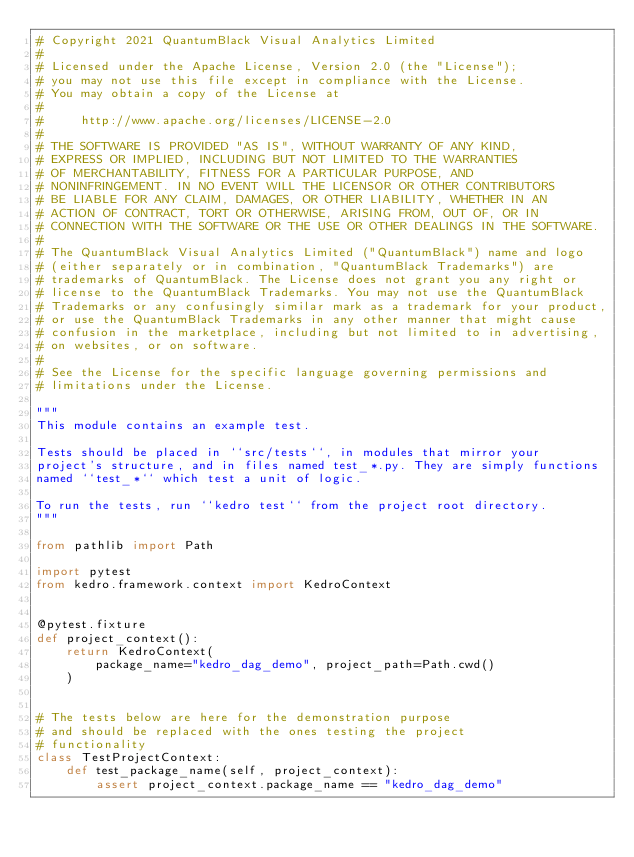<code> <loc_0><loc_0><loc_500><loc_500><_Python_># Copyright 2021 QuantumBlack Visual Analytics Limited
#
# Licensed under the Apache License, Version 2.0 (the "License");
# you may not use this file except in compliance with the License.
# You may obtain a copy of the License at
#
#     http://www.apache.org/licenses/LICENSE-2.0
#
# THE SOFTWARE IS PROVIDED "AS IS", WITHOUT WARRANTY OF ANY KIND,
# EXPRESS OR IMPLIED, INCLUDING BUT NOT LIMITED TO THE WARRANTIES
# OF MERCHANTABILITY, FITNESS FOR A PARTICULAR PURPOSE, AND
# NONINFRINGEMENT. IN NO EVENT WILL THE LICENSOR OR OTHER CONTRIBUTORS
# BE LIABLE FOR ANY CLAIM, DAMAGES, OR OTHER LIABILITY, WHETHER IN AN
# ACTION OF CONTRACT, TORT OR OTHERWISE, ARISING FROM, OUT OF, OR IN
# CONNECTION WITH THE SOFTWARE OR THE USE OR OTHER DEALINGS IN THE SOFTWARE.
#
# The QuantumBlack Visual Analytics Limited ("QuantumBlack") name and logo
# (either separately or in combination, "QuantumBlack Trademarks") are
# trademarks of QuantumBlack. The License does not grant you any right or
# license to the QuantumBlack Trademarks. You may not use the QuantumBlack
# Trademarks or any confusingly similar mark as a trademark for your product,
# or use the QuantumBlack Trademarks in any other manner that might cause
# confusion in the marketplace, including but not limited to in advertising,
# on websites, or on software.
#
# See the License for the specific language governing permissions and
# limitations under the License.

"""
This module contains an example test.

Tests should be placed in ``src/tests``, in modules that mirror your
project's structure, and in files named test_*.py. They are simply functions
named ``test_*`` which test a unit of logic.

To run the tests, run ``kedro test`` from the project root directory.
"""

from pathlib import Path

import pytest
from kedro.framework.context import KedroContext


@pytest.fixture
def project_context():
    return KedroContext(
        package_name="kedro_dag_demo", project_path=Path.cwd()
    )


# The tests below are here for the demonstration purpose
# and should be replaced with the ones testing the project
# functionality
class TestProjectContext:
    def test_package_name(self, project_context):
        assert project_context.package_name == "kedro_dag_demo"
</code> 